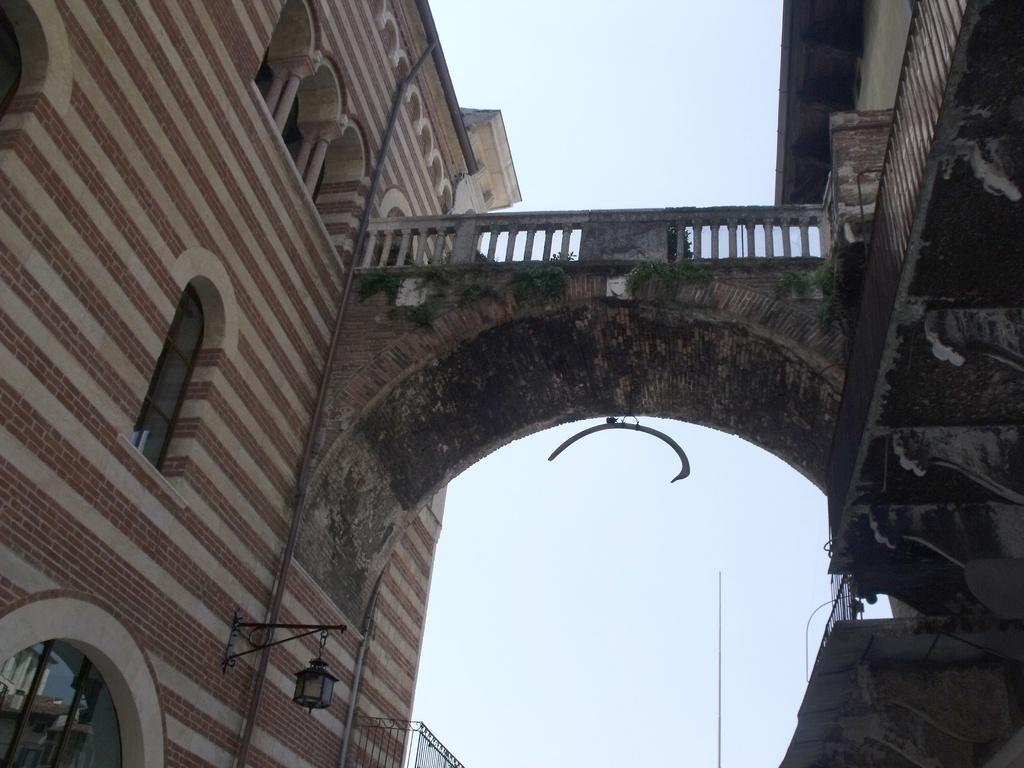How many buildings can be seen in the image? There are two buildings in the image. Is there any connection between the two buildings? Yes, there is a bridge connecting the two buildings. What can be seen in the background of the image? The sky is visible in the background of the image. What type of leather is used to cover the bridge in the image? There is no leather present in the image, as the bridge is likely made of a different material, such as metal or concrete. 